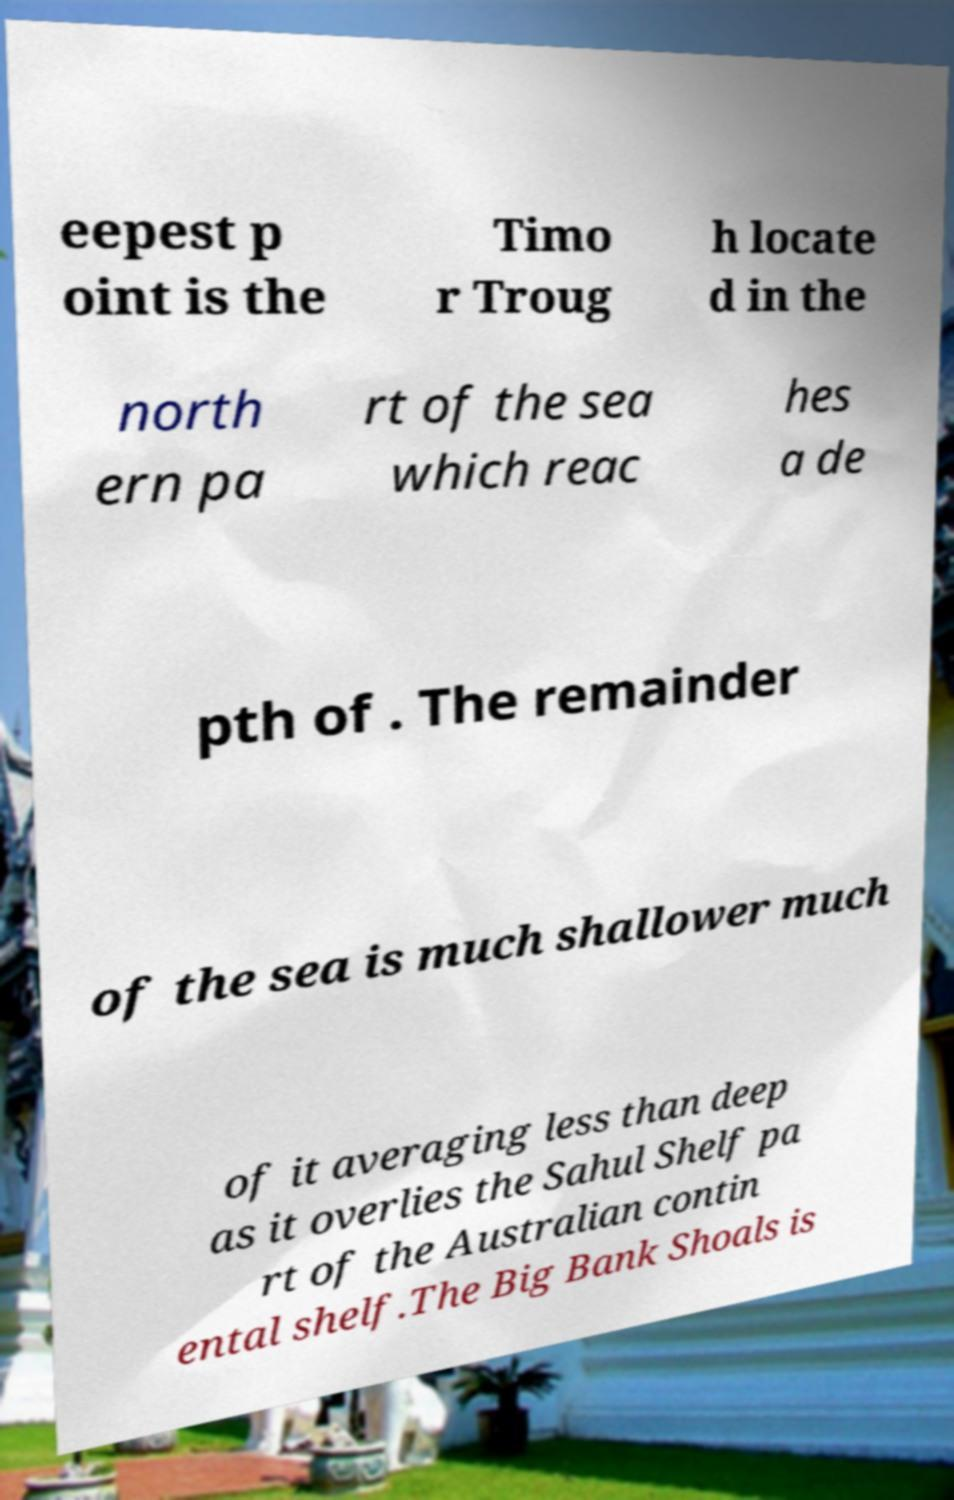For documentation purposes, I need the text within this image transcribed. Could you provide that? eepest p oint is the Timo r Troug h locate d in the north ern pa rt of the sea which reac hes a de pth of . The remainder of the sea is much shallower much of it averaging less than deep as it overlies the Sahul Shelf pa rt of the Australian contin ental shelf.The Big Bank Shoals is 